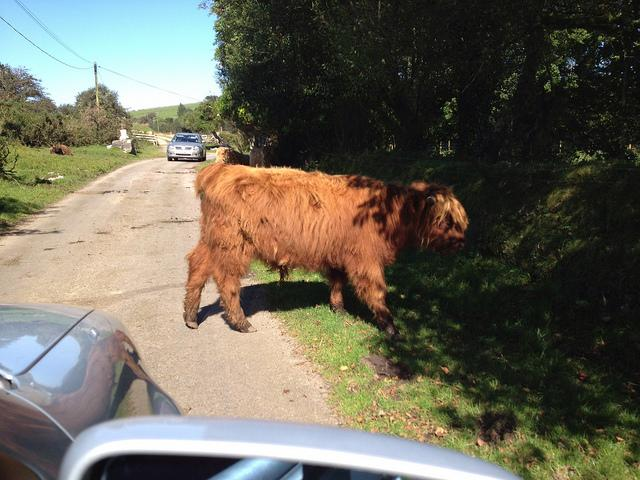What type of animal is shown?

Choices:
A) domestic
B) aquatic
C) wild
D) stuffed wild 